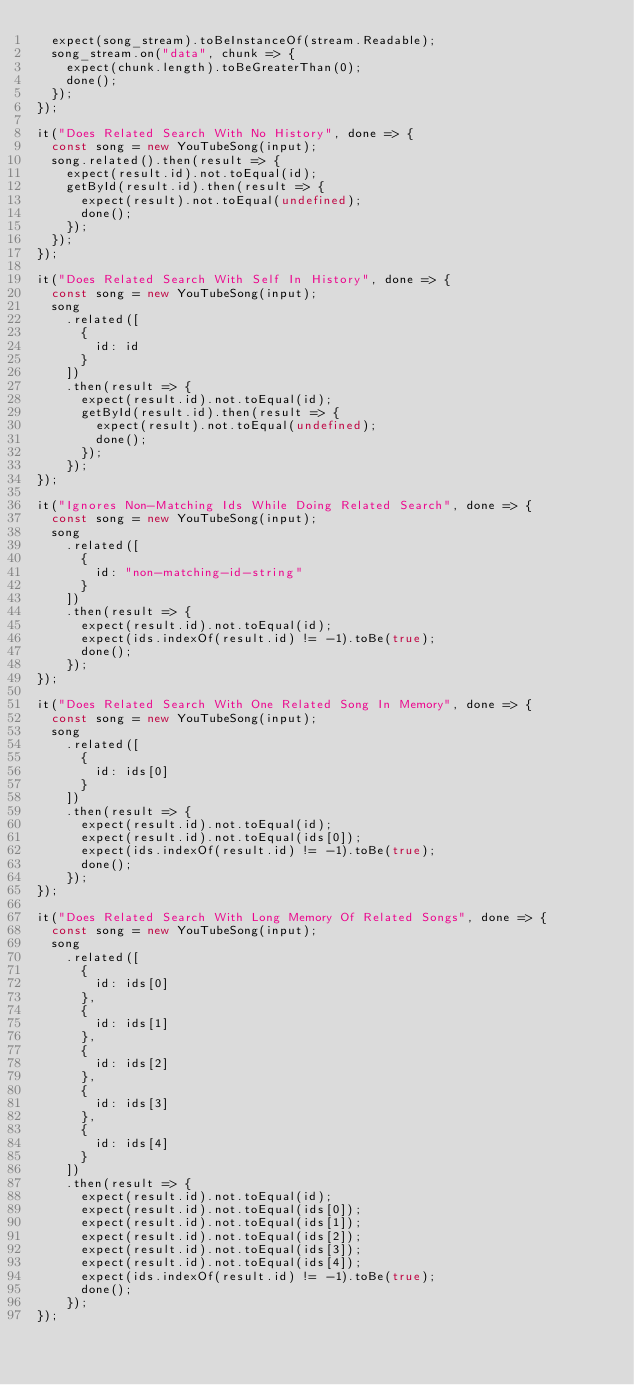Convert code to text. <code><loc_0><loc_0><loc_500><loc_500><_JavaScript_>  expect(song_stream).toBeInstanceOf(stream.Readable);
  song_stream.on("data", chunk => {
    expect(chunk.length).toBeGreaterThan(0);
    done();
  });
});

it("Does Related Search With No History", done => {
  const song = new YouTubeSong(input);
  song.related().then(result => {
    expect(result.id).not.toEqual(id);
    getById(result.id).then(result => {
      expect(result).not.toEqual(undefined);
      done();
    });
  });
});

it("Does Related Search With Self In History", done => {
  const song = new YouTubeSong(input);
  song
    .related([
      {
        id: id
      }
    ])
    .then(result => {
      expect(result.id).not.toEqual(id);
      getById(result.id).then(result => {
        expect(result).not.toEqual(undefined);
        done();
      });
    });
});

it("Ignores Non-Matching Ids While Doing Related Search", done => {
  const song = new YouTubeSong(input);
  song
    .related([
      {
        id: "non-matching-id-string"
      }
    ])
    .then(result => {
      expect(result.id).not.toEqual(id);
      expect(ids.indexOf(result.id) != -1).toBe(true);
      done();
    });
});

it("Does Related Search With One Related Song In Memory", done => {
  const song = new YouTubeSong(input);
  song
    .related([
      {
        id: ids[0]
      }
    ])
    .then(result => {
      expect(result.id).not.toEqual(id);
      expect(result.id).not.toEqual(ids[0]);
      expect(ids.indexOf(result.id) != -1).toBe(true);
      done();
    });
});

it("Does Related Search With Long Memory Of Related Songs", done => {
  const song = new YouTubeSong(input);
  song
    .related([
      {
        id: ids[0]
      },
      {
        id: ids[1]
      },
      {
        id: ids[2]
      },
      {
        id: ids[3]
      },
      {
        id: ids[4]
      }
    ])
    .then(result => {
      expect(result.id).not.toEqual(id);
      expect(result.id).not.toEqual(ids[0]);
      expect(result.id).not.toEqual(ids[1]);
      expect(result.id).not.toEqual(ids[2]);
      expect(result.id).not.toEqual(ids[3]);
      expect(result.id).not.toEqual(ids[4]);
      expect(ids.indexOf(result.id) != -1).toBe(true);
      done();
    });
});
</code> 